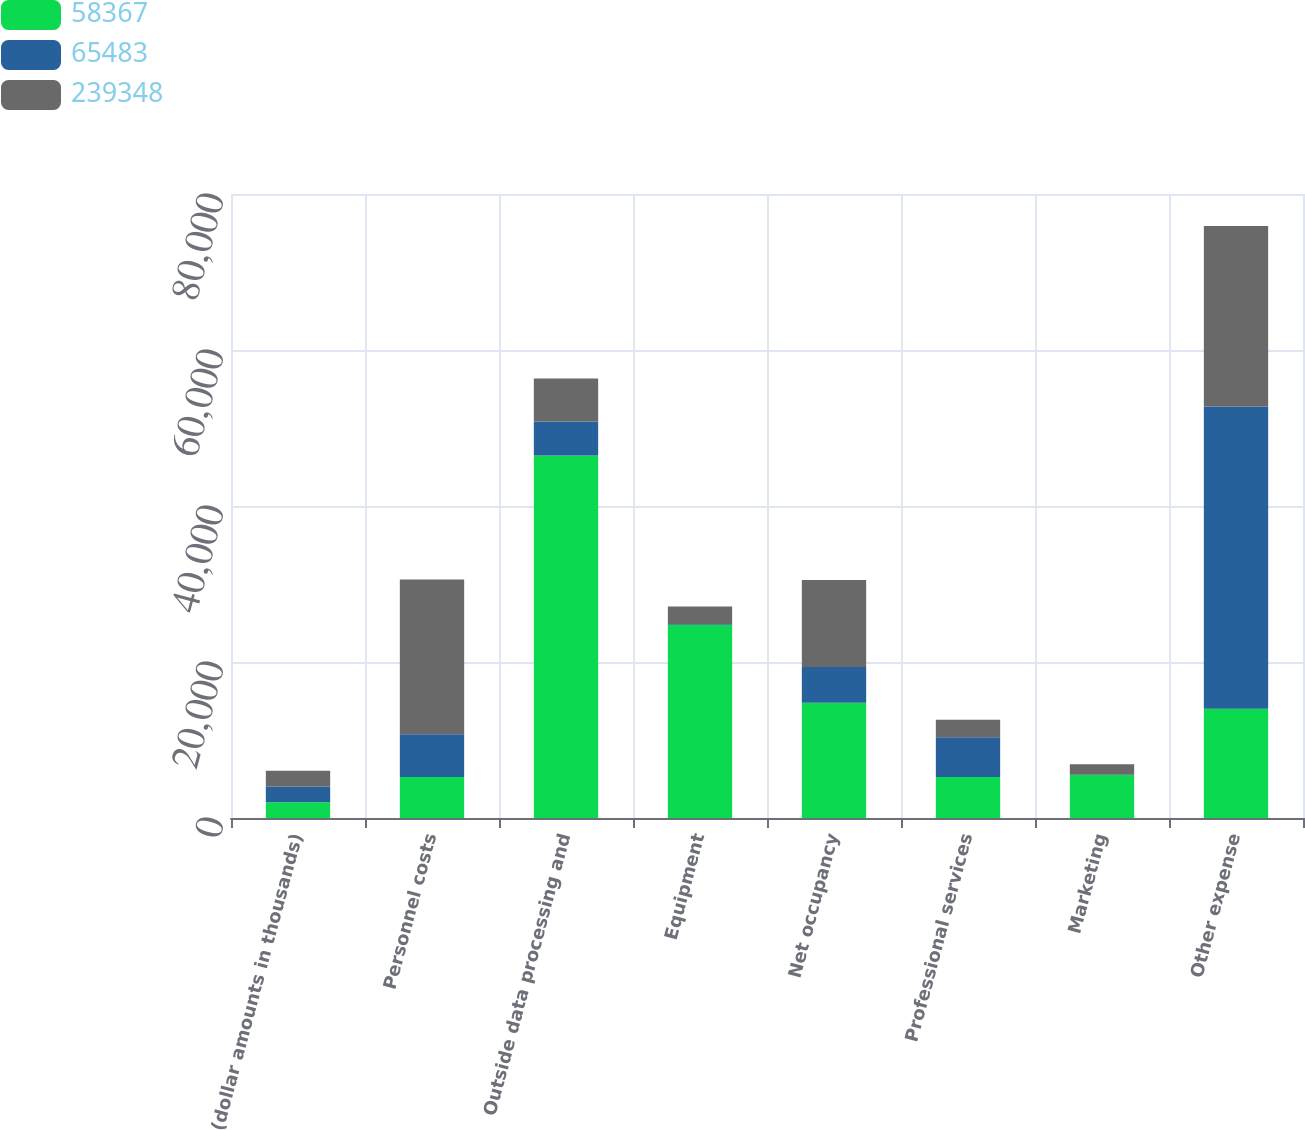<chart> <loc_0><loc_0><loc_500><loc_500><stacked_bar_chart><ecel><fcel>(dollar amounts in thousands)<fcel>Personnel costs<fcel>Outside data processing and<fcel>Equipment<fcel>Net occupancy<fcel>Professional services<fcel>Marketing<fcel>Other expense<nl><fcel>58367<fcel>2016<fcel>5272<fcel>46467<fcel>24742<fcel>14772<fcel>5272<fcel>5520<fcel>14010<nl><fcel>65483<fcel>2015<fcel>5457<fcel>4365<fcel>110<fcel>4587<fcel>5087<fcel>28<fcel>38733<nl><fcel>239348<fcel>2014<fcel>19850<fcel>5507<fcel>2248<fcel>11153<fcel>2228<fcel>1357<fcel>23140<nl></chart> 